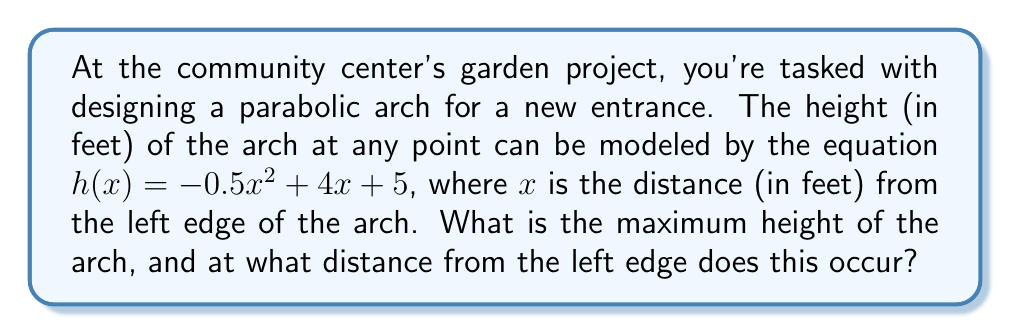Can you answer this question? To find the maximum height of the parabolic arch, we need to find the vertex of the parabola. For a quadratic function in the form $f(x) = ax^2 + bx + c$, the x-coordinate of the vertex is given by $x = -\frac{b}{2a}$.

1) First, identify the coefficients in our equation $h(x) = -0.5x^2 + 4x + 5$:
   $a = -0.5$, $b = 4$, and $c = 5$

2) Calculate the x-coordinate of the vertex:
   $x = -\frac{b}{2a} = -\frac{4}{2(-0.5)} = -\frac{4}{-1} = 4$

3) To find the maximum height, substitute $x = 4$ into the original equation:
   $h(4) = -0.5(4)^2 + 4(4) + 5$
   $= -0.5(16) + 16 + 5$
   $= -8 + 16 + 5$
   $= 13$

Therefore, the maximum height occurs 4 feet from the left edge of the arch, and the maximum height is 13 feet.
Answer: The maximum height of the arch is 13 feet, occurring 4 feet from the left edge. 